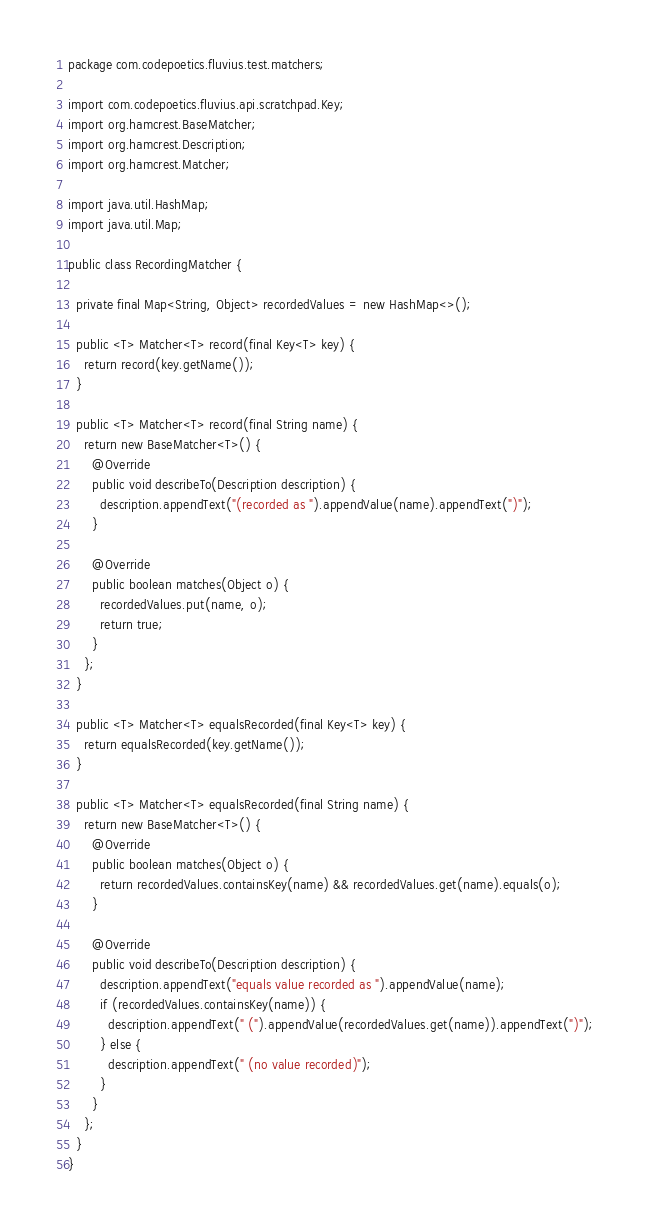Convert code to text. <code><loc_0><loc_0><loc_500><loc_500><_Java_>package com.codepoetics.fluvius.test.matchers;

import com.codepoetics.fluvius.api.scratchpad.Key;
import org.hamcrest.BaseMatcher;
import org.hamcrest.Description;
import org.hamcrest.Matcher;

import java.util.HashMap;
import java.util.Map;

public class RecordingMatcher {

  private final Map<String, Object> recordedValues = new HashMap<>();

  public <T> Matcher<T> record(final Key<T> key) {
    return record(key.getName());
  }

  public <T> Matcher<T> record(final String name) {
    return new BaseMatcher<T>() {
      @Override
      public void describeTo(Description description) {
        description.appendText("(recorded as ").appendValue(name).appendText(")");
      }

      @Override
      public boolean matches(Object o) {
        recordedValues.put(name, o);
        return true;
      }
    };
  }

  public <T> Matcher<T> equalsRecorded(final Key<T> key) {
    return equalsRecorded(key.getName());
  }

  public <T> Matcher<T> equalsRecorded(final String name) {
    return new BaseMatcher<T>() {
      @Override
      public boolean matches(Object o) {
        return recordedValues.containsKey(name) && recordedValues.get(name).equals(o);
      }

      @Override
      public void describeTo(Description description) {
        description.appendText("equals value recorded as ").appendValue(name);
        if (recordedValues.containsKey(name)) {
          description.appendText(" (").appendValue(recordedValues.get(name)).appendText(")");
        } else {
          description.appendText(" (no value recorded)");
        }
      }
    };
  }
}
</code> 